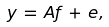Convert formula to latex. <formula><loc_0><loc_0><loc_500><loc_500>y \, = \, A f \, + \, e ,</formula> 